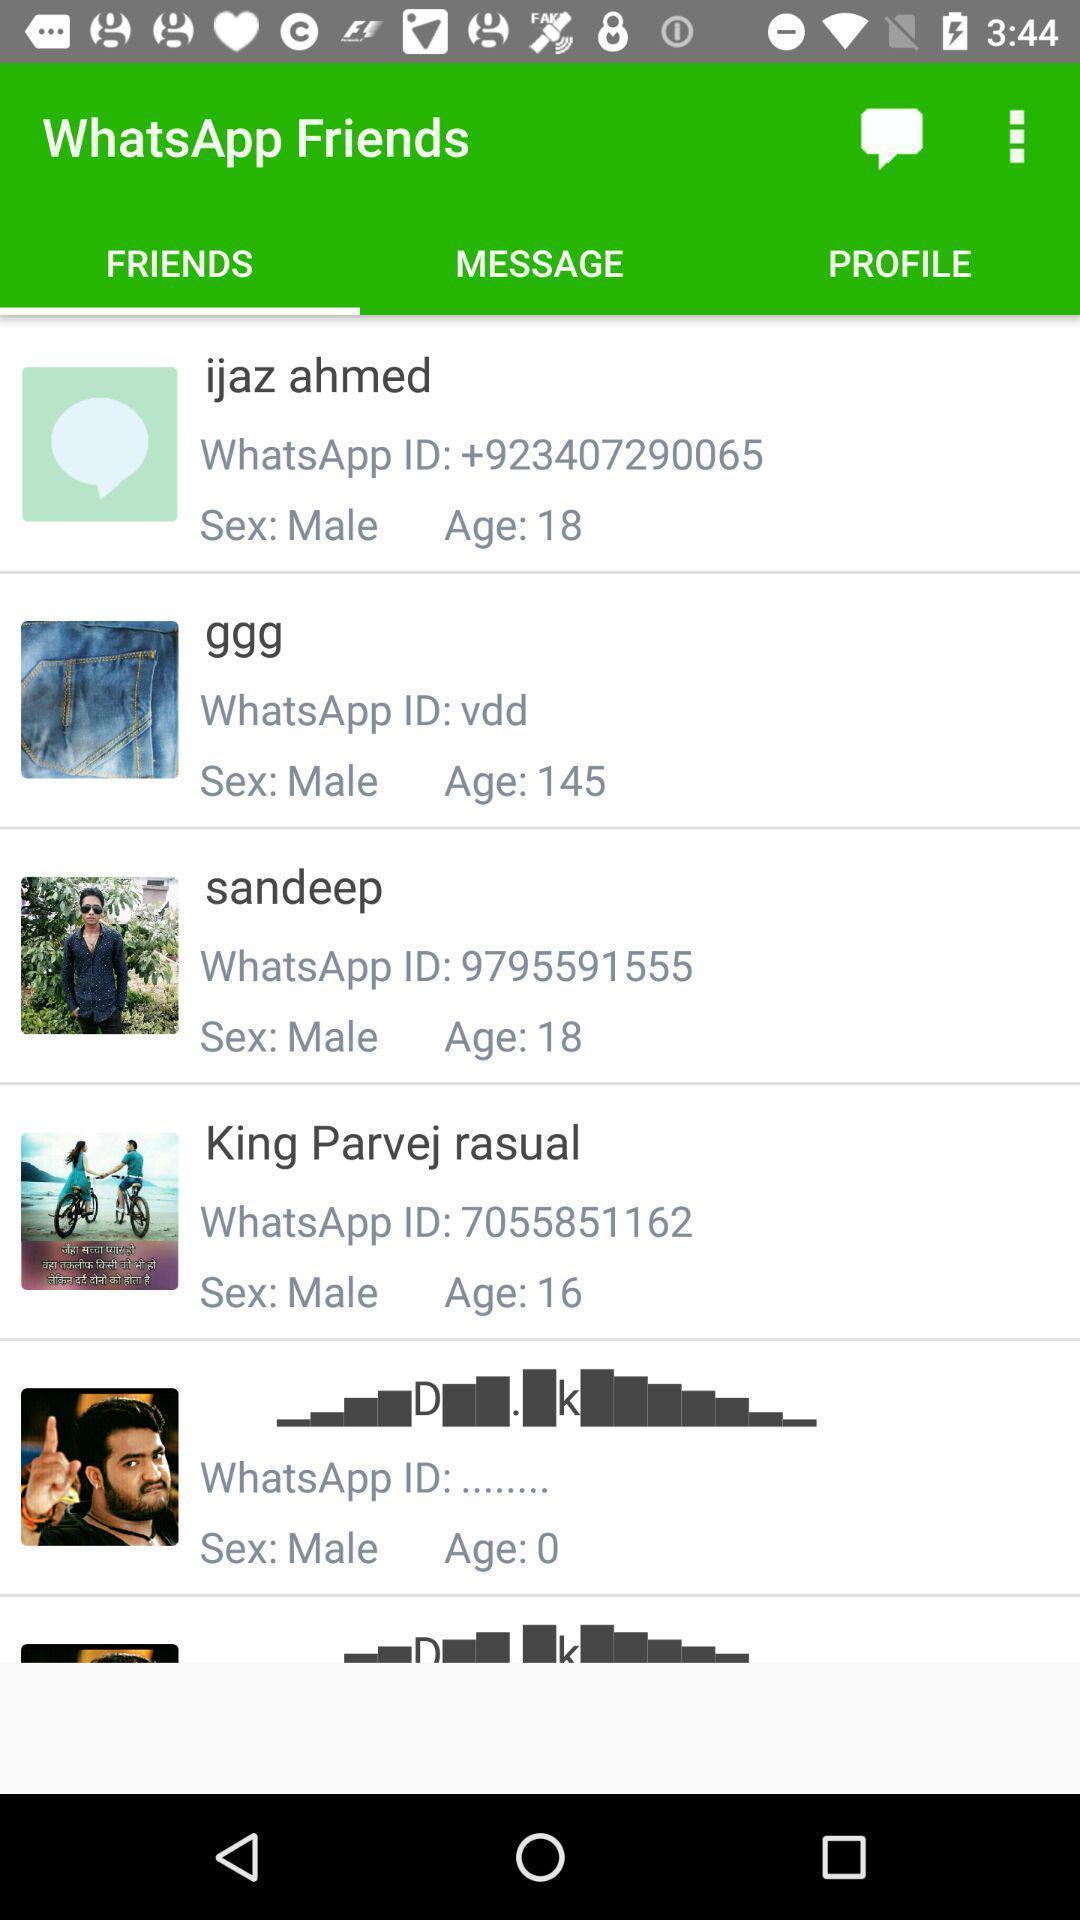Tell me about the visual elements in this screen capture. Social media app page shows friends list and their details. 